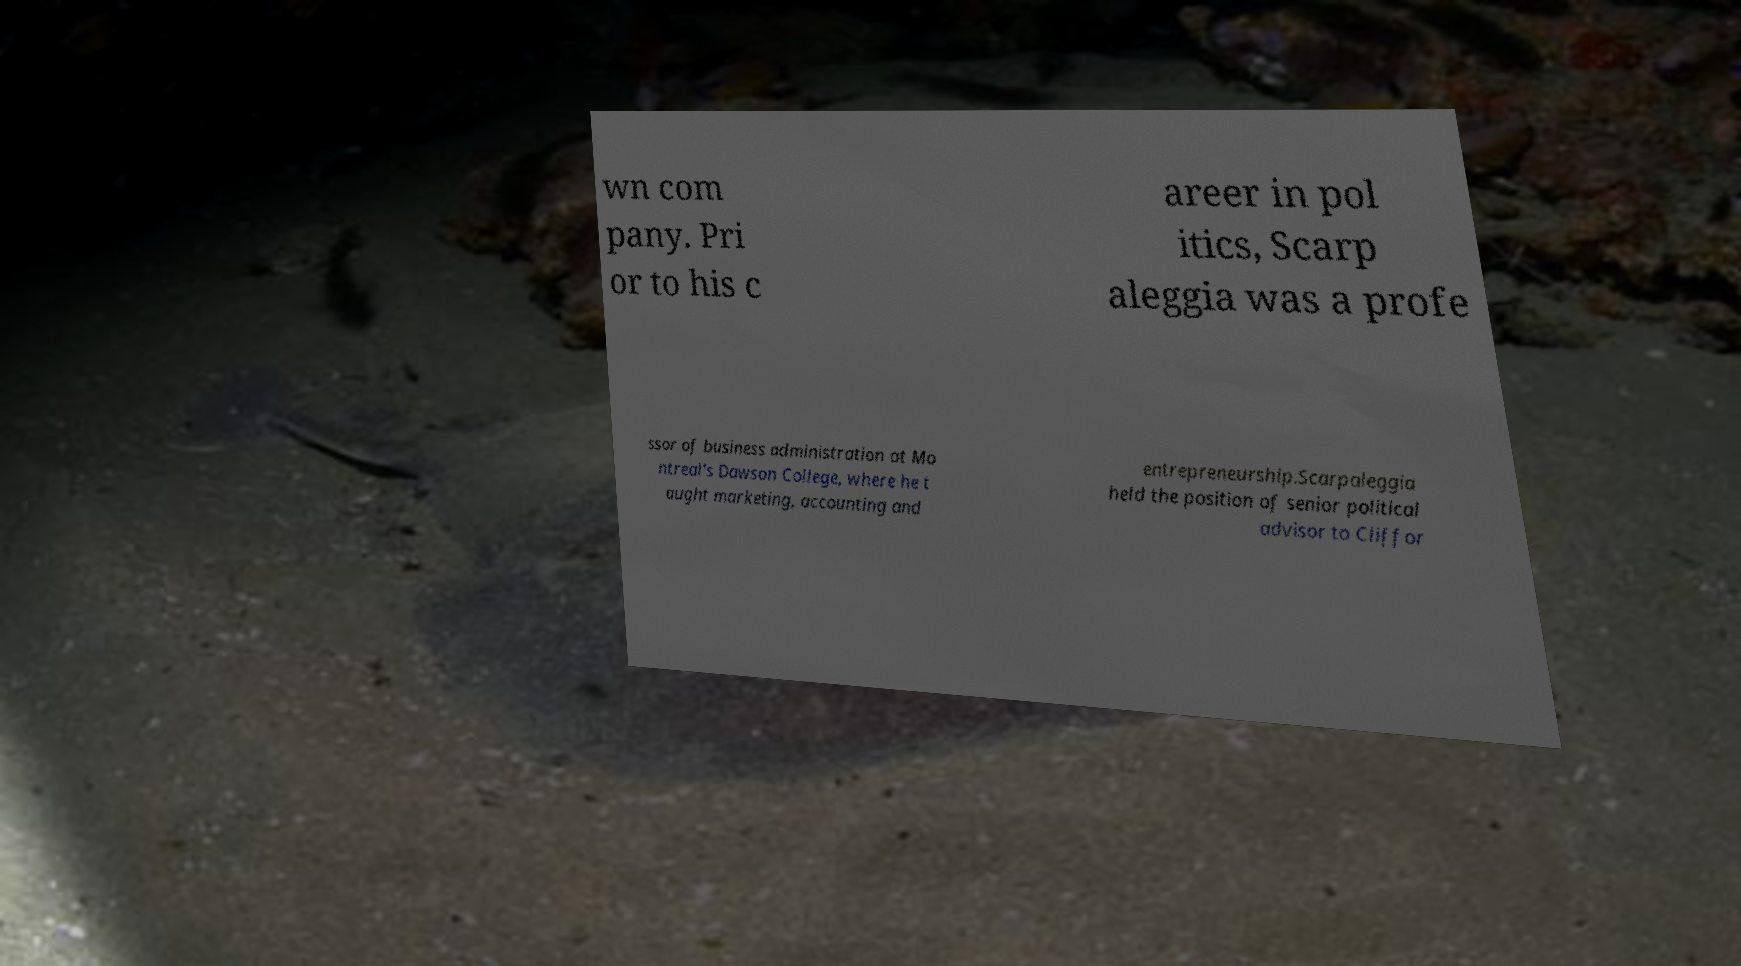Can you accurately transcribe the text from the provided image for me? wn com pany. Pri or to his c areer in pol itics, Scarp aleggia was a profe ssor of business administration at Mo ntreal's Dawson College, where he t aught marketing, accounting and entrepreneurship.Scarpaleggia held the position of senior political advisor to Cliffor 